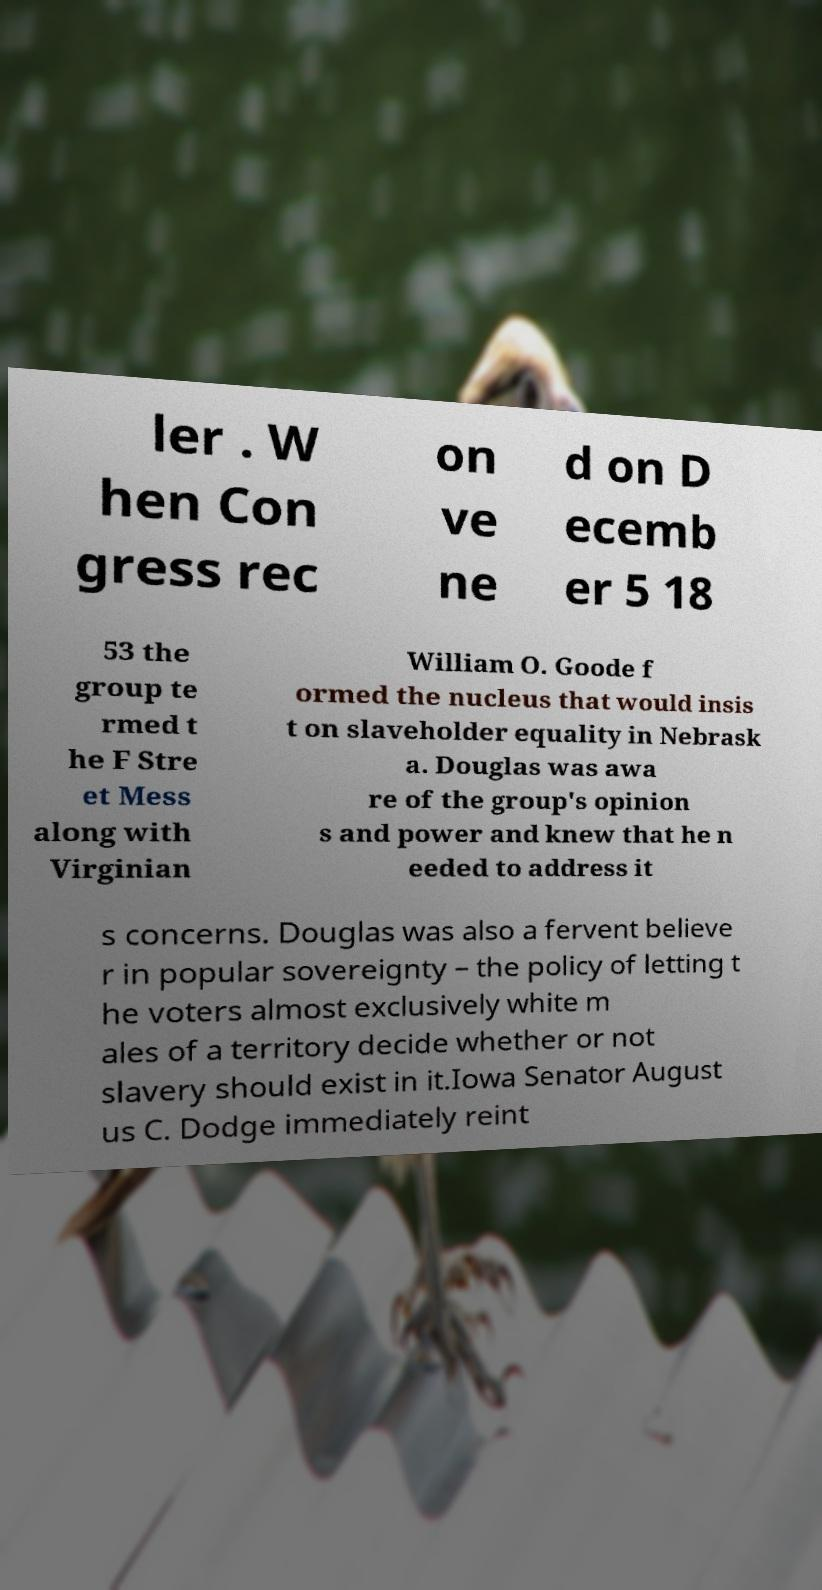What messages or text are displayed in this image? I need them in a readable, typed format. ler . W hen Con gress rec on ve ne d on D ecemb er 5 18 53 the group te rmed t he F Stre et Mess along with Virginian William O. Goode f ormed the nucleus that would insis t on slaveholder equality in Nebrask a. Douglas was awa re of the group's opinion s and power and knew that he n eeded to address it s concerns. Douglas was also a fervent believe r in popular sovereignty – the policy of letting t he voters almost exclusively white m ales of a territory decide whether or not slavery should exist in it.Iowa Senator August us C. Dodge immediately reint 